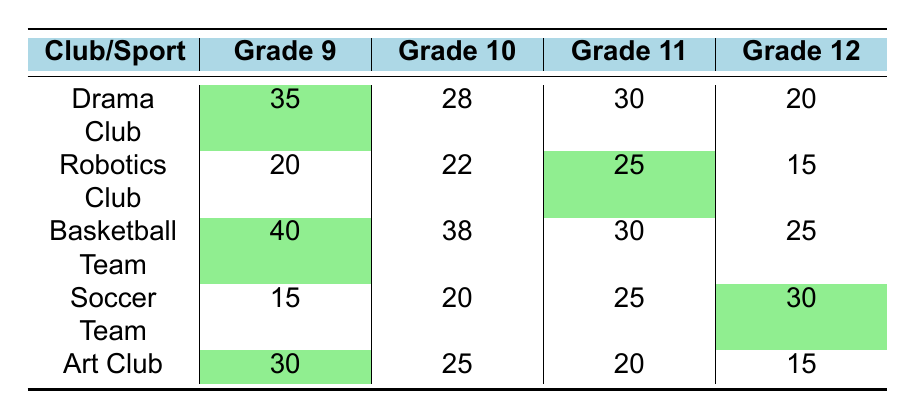What is the participation rate for the Basketball Team in Grade 9? Referring to the table, the participation rate for the Basketball Team in Grade 9 is listed as 40.
Answer: 40 Which club has the highest participation in Grade 10? By looking at the values for Grade 10, the Drama Club has 28, Robotics Club has 22, Basketball Team has 38, Soccer Team has 20, and Art Club has 25. The Basketball Team has the highest participation at 38.
Answer: 38 How many participants are there in total for the Robotics Club across all grades? To find the total participants for the Robotics Club, add the values from each grade: 20 (Grade 9) + 22 (Grade 10) + 25 (Grade 11) + 15 (Grade 12) = 82.
Answer: 82 Is the participation rate in the Art Club for Grade 12 higher than that for Grade 11? The participation rate for the Art Club in Grade 12 is 15, and in Grade 11 it is 20. Since 15 is less than 20, the statement is false.
Answer: No What is the average participation rate for the Soccer Team across all grades? To calculate the average, add the participation rates: 15 (Grade 9) + 20 (Grade 10) + 25 (Grade 11) + 30 (Grade 12) = 90. Then, divide by the number of grades: 90/4 = 22.5.
Answer: 22.5 Which club had a higher participation rate in Grade 11: Drama Club or Basketball Team? The Drama Club had 30 participants in Grade 11, while the Basketball Team had 30 as well. Therefore, they are equal, not higher.
Answer: They are equal If we want to know the overall club participation in Grade 12, what is the sum of participants across all clubs for that grade? The sums for Grade 12 are: Drama Club 20 + Robotics Club 15 + Basketball Team 25 + Soccer Team 30 + Art Club 15 = 105.
Answer: 105 In which grade does the Art Club have its lowest participation, and what is the number? The Art Club participation rates are 30 (Grade 9), 25 (Grade 10), 20 (Grade 11), and 15 (Grade 12). The lowest is in Grade 12 with 15 participants.
Answer: Grade 12, 15 Is the total participation in clubs for Grade 9 greater than that for Grade 11? The total for Grade 9 is 35 (Drama Club) + 20 (Robotics Club) + 40 (Basketball Team) + 15 (Soccer Team) + 30 (Art Club) = 140. Grade 11 total is 30 + 25 + 30 + 25 + 20 = 130. Since 140 is greater than 130, the statement is true.
Answer: Yes How many more participants are there in Grade 10's Basketball Team compared to Grade 12's? The participation rate in Grade 10's Basketball Team is 38, while in Grade 12 it is 25. Therefore, the difference is 38 - 25 = 13.
Answer: 13 